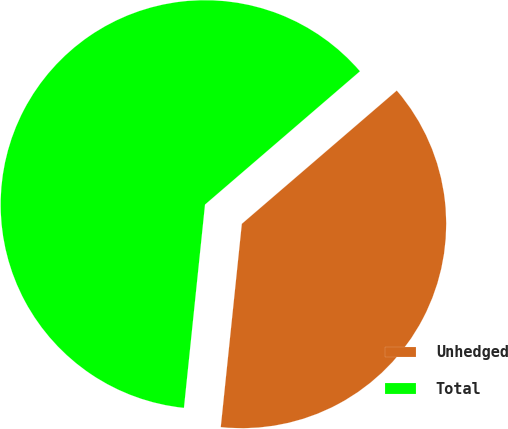<chart> <loc_0><loc_0><loc_500><loc_500><pie_chart><fcel>Unhedged<fcel>Total<nl><fcel>37.95%<fcel>62.05%<nl></chart> 